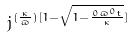<formula> <loc_0><loc_0><loc_500><loc_500>j ^ { ( \frac { \kappa } { \varpi } ) [ 1 - \sqrt { 1 - \frac { 0 \varpi ^ { 0 } t } { \kappa } } ] }</formula> 